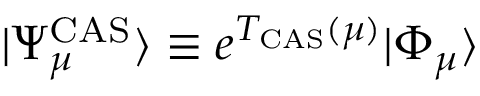Convert formula to latex. <formula><loc_0><loc_0><loc_500><loc_500>| \Psi _ { \mu } ^ { C A S } \rangle \equiv e ^ { T _ { C A S } ( \mu ) } | \Phi _ { \mu } \rangle</formula> 